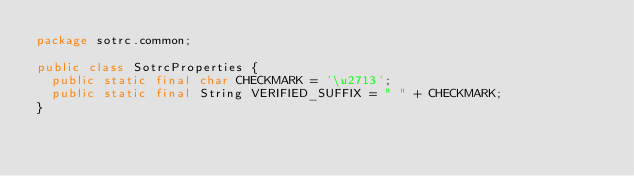<code> <loc_0><loc_0><loc_500><loc_500><_Java_>package sotrc.common;

public class SotrcProperties {
	public static final char CHECKMARK = '\u2713';
	public static final String VERIFIED_SUFFIX = " " + CHECKMARK;
}
</code> 